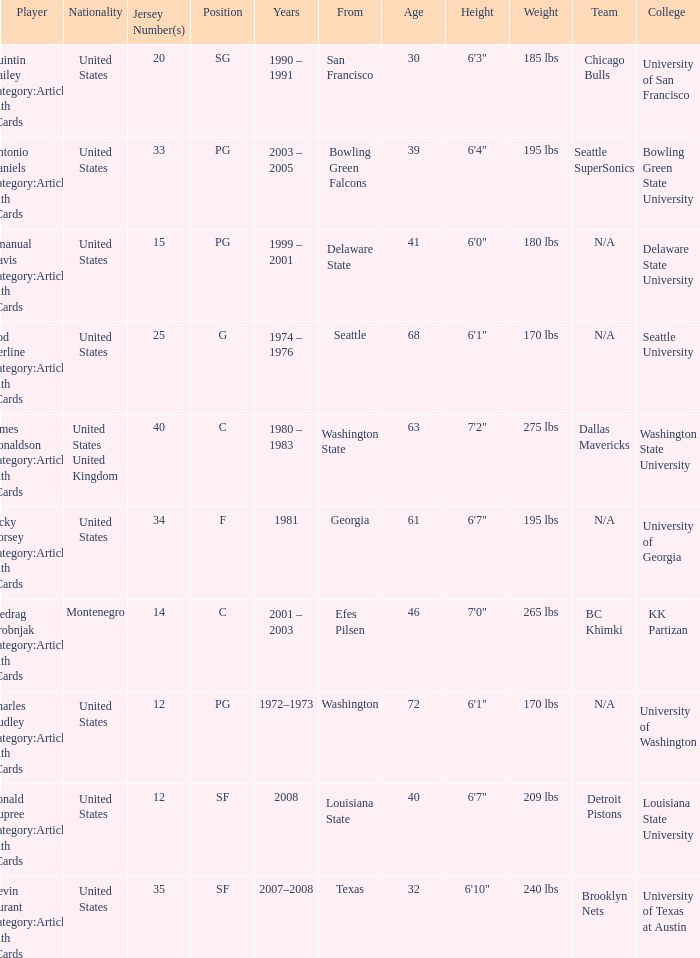What college was the player with the jersey number of 34 from? Georgia. Would you be able to parse every entry in this table? {'header': ['Player', 'Nationality', 'Jersey Number(s)', 'Position', 'Years', 'From', 'Age', 'Height', 'Weight', 'Team', 'College '], 'rows': [['Quintin Dailey Category:Articles with hCards', 'United States', '20', 'SG', '1990 – 1991', 'San Francisco', '30', '6\'3"', '185 lbs', 'Chicago Bulls', 'University of San Francisco'], ['Antonio Daniels Category:Articles with hCards', 'United States', '33', 'PG', '2003 – 2005', 'Bowling Green Falcons', '39', '6\'4"', '195 lbs', 'Seattle SuperSonics', 'Bowling Green State University'], ['Emanual Davis Category:Articles with hCards', 'United States', '15', 'PG', '1999 – 2001', 'Delaware State', '41', '6\'0"', '180 lbs', 'N/A', 'Delaware State University'], ['Rod Derline Category:Articles with hCards', 'United States', '25', 'G', '1974 – 1976', 'Seattle', '68', '6\'1"', '170 lbs', 'N/A', 'Seattle University'], ['James Donaldson Category:Articles with hCards', 'United States United Kingdom', '40', 'C', '1980 – 1983', 'Washington State', '63', '7\'2"', '275 lbs', 'Dallas Mavericks', 'Washington State University'], ['Jacky Dorsey Category:Articles with hCards', 'United States', '34', 'F', '1981', 'Georgia', '61', '6\'7"', '195 lbs', 'N/A', 'University of Georgia'], ['Predrag Drobnjak Category:Articles with hCards', 'Montenegro', '14', 'C', '2001 – 2003', 'Efes Pilsen', '46', '7\'0"', '265 lbs', 'BC Khimki', 'KK Partizan'], ['Charles Dudley Category:Articles with hCards', 'United States', '12', 'PG', '1972–1973', 'Washington', '72', '6\'1"', '170 lbs', 'N/A', 'University of Washington'], ['Ronald Dupree Category:Articles with hCards', 'United States', '12', 'SF', '2008', 'Louisiana State', '40', '6\'7"', '209 lbs', 'Detroit Pistons', 'Louisiana State University'], ['Kevin Durant Category:Articles with hCards', 'United States', '35', 'SF', '2007–2008', 'Texas', '32', '6\'10"', '240 lbs', 'Brooklyn Nets', 'University of Texas at Austin']]} 